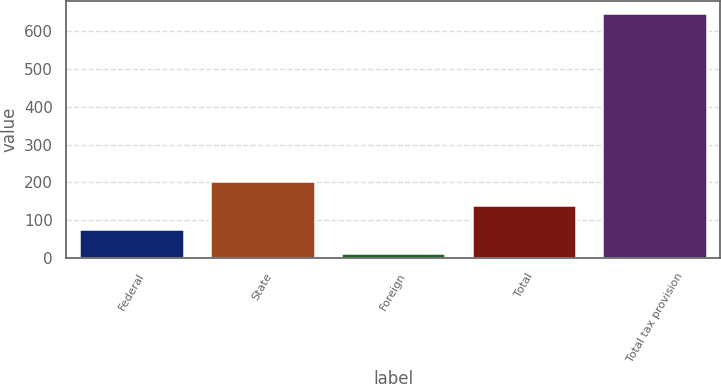<chart> <loc_0><loc_0><loc_500><loc_500><bar_chart><fcel>Federal<fcel>State<fcel>Foreign<fcel>Total<fcel>Total tax provision<nl><fcel>76.5<fcel>203.5<fcel>13<fcel>140<fcel>648<nl></chart> 